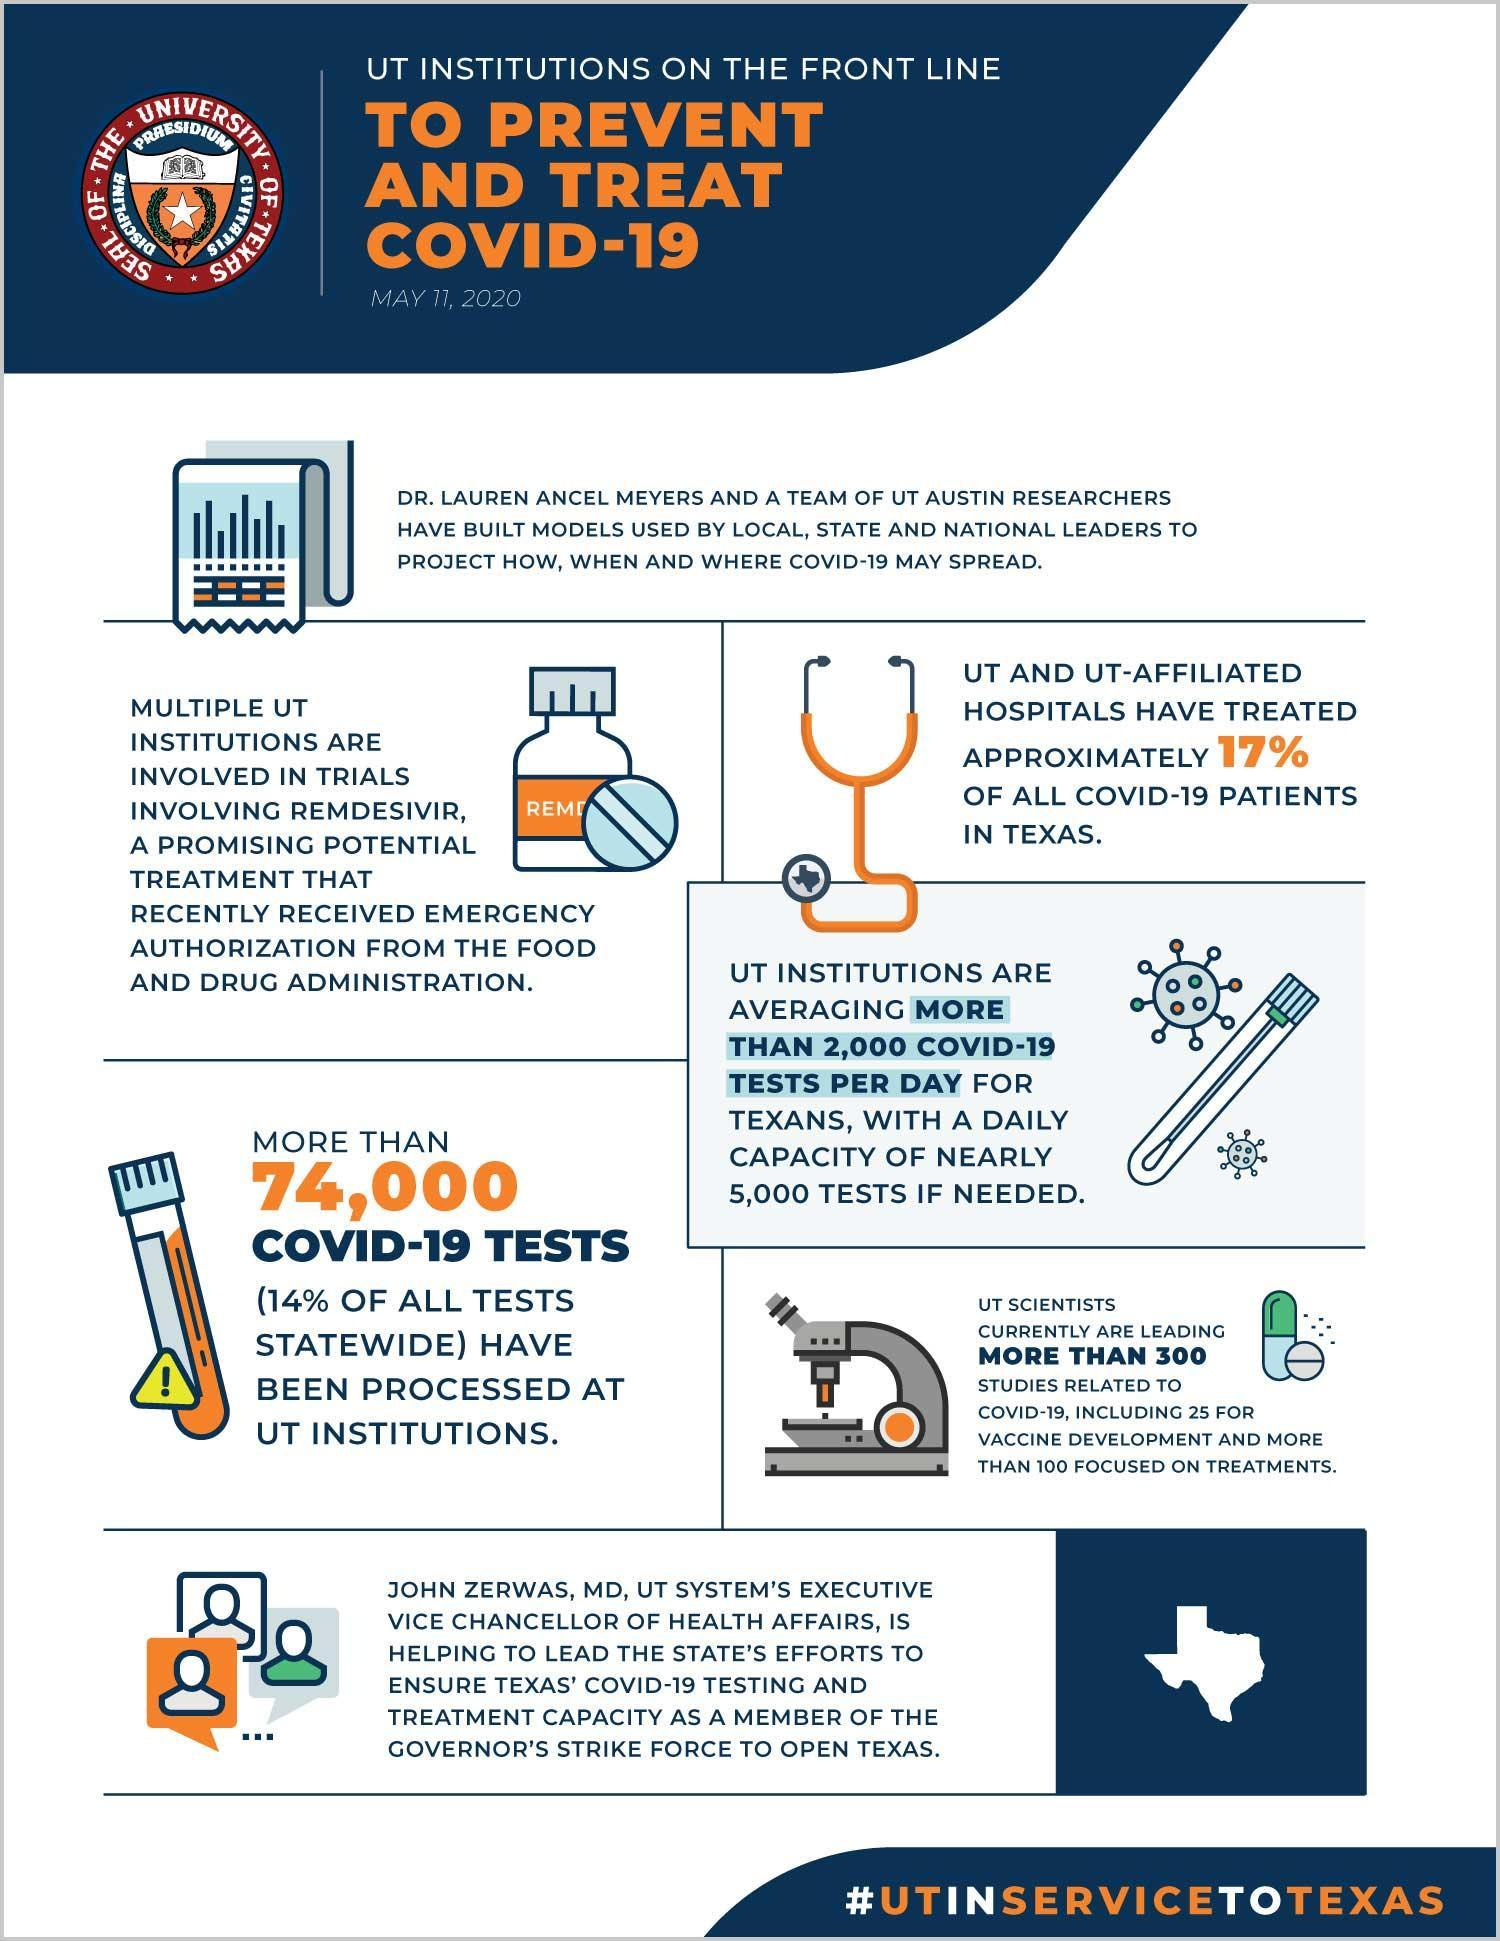How many studies have been made for vaccine development by the UT scientists (approx)?
Answer the question with a short phrase. 25 Who is responsible for the treatment of around 17% of covid-19 patients in Texas? UT and UT affiliated hospitals Of the 300 studies, how many have been made for covid-19 'treatments' by the UT scientists (approx)? 100 Which is the drug that received emergency authorisation from the food and drug administration? Remdesivir 